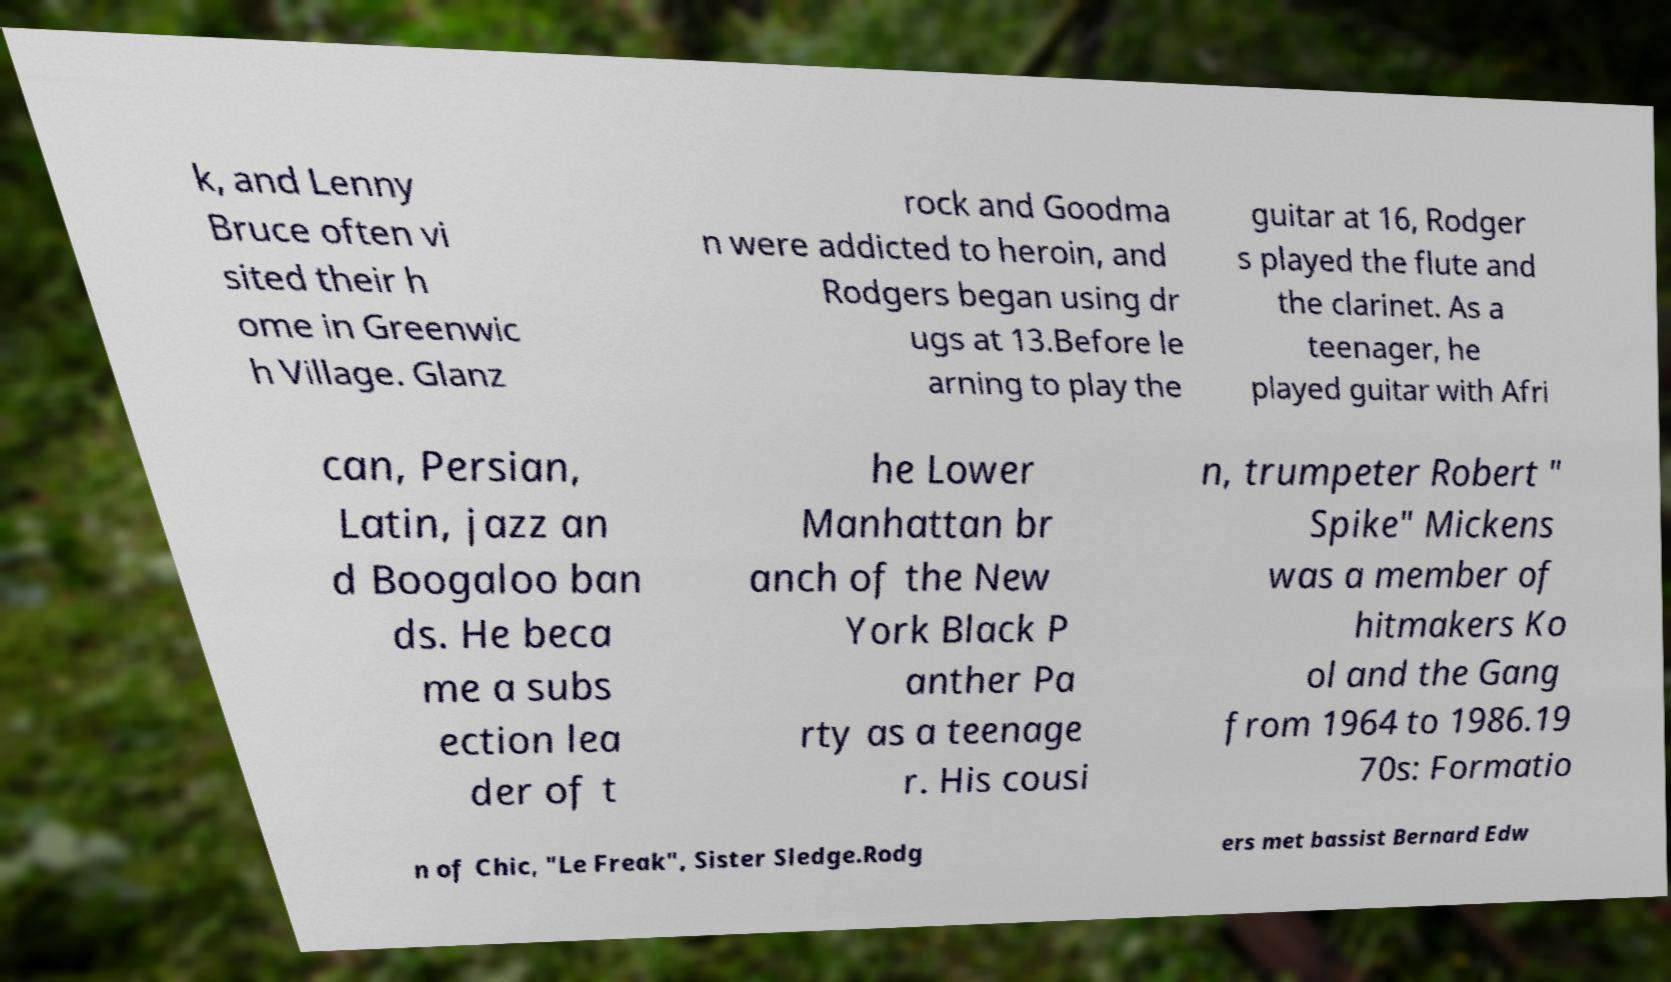Could you extract and type out the text from this image? k, and Lenny Bruce often vi sited their h ome in Greenwic h Village. Glanz rock and Goodma n were addicted to heroin, and Rodgers began using dr ugs at 13.Before le arning to play the guitar at 16, Rodger s played the flute and the clarinet. As a teenager, he played guitar with Afri can, Persian, Latin, jazz an d Boogaloo ban ds. He beca me a subs ection lea der of t he Lower Manhattan br anch of the New York Black P anther Pa rty as a teenage r. His cousi n, trumpeter Robert " Spike" Mickens was a member of hitmakers Ko ol and the Gang from 1964 to 1986.19 70s: Formatio n of Chic, "Le Freak", Sister Sledge.Rodg ers met bassist Bernard Edw 